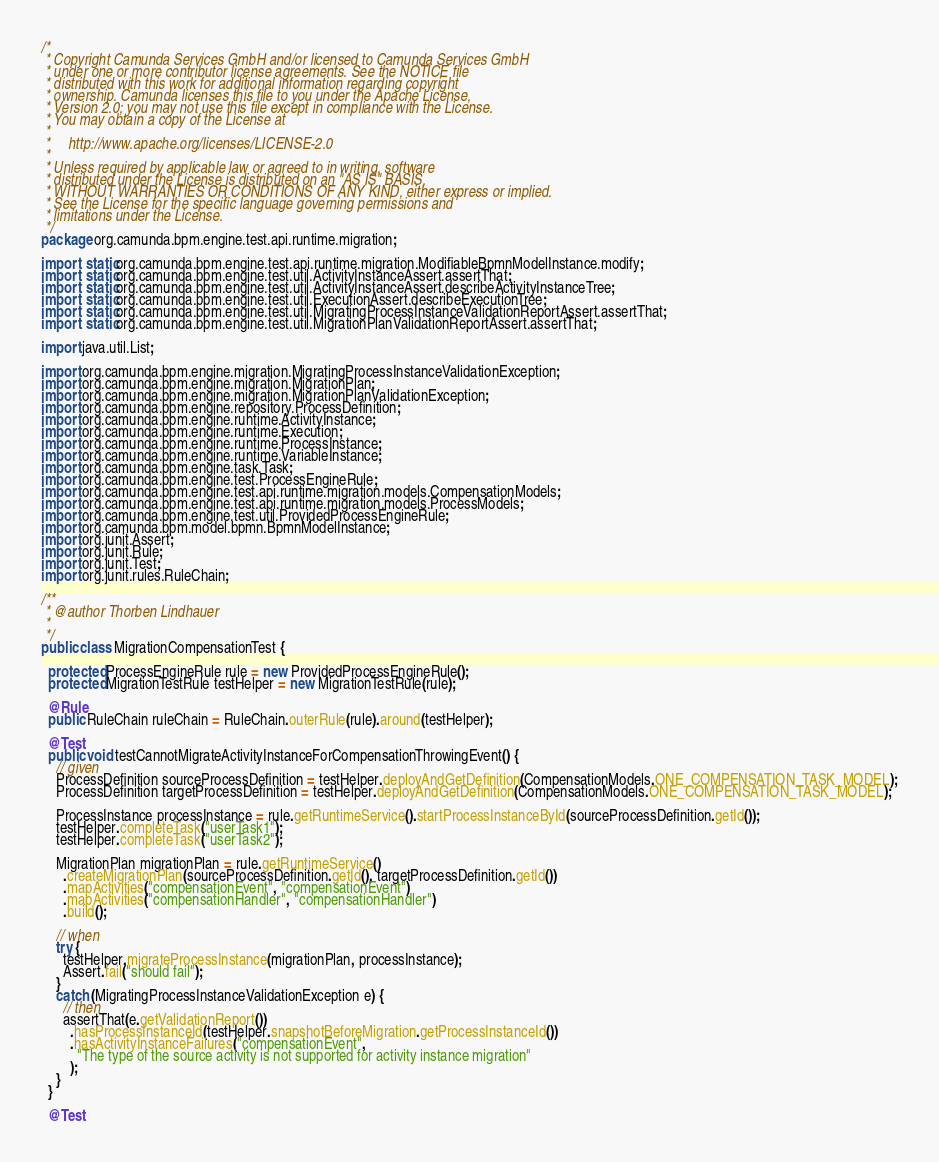Convert code to text. <code><loc_0><loc_0><loc_500><loc_500><_Java_>/*
 * Copyright Camunda Services GmbH and/or licensed to Camunda Services GmbH
 * under one or more contributor license agreements. See the NOTICE file
 * distributed with this work for additional information regarding copyright
 * ownership. Camunda licenses this file to you under the Apache License,
 * Version 2.0; you may not use this file except in compliance with the License.
 * You may obtain a copy of the License at
 *
 *     http://www.apache.org/licenses/LICENSE-2.0
 *
 * Unless required by applicable law or agreed to in writing, software
 * distributed under the License is distributed on an "AS IS" BASIS,
 * WITHOUT WARRANTIES OR CONDITIONS OF ANY KIND, either express or implied.
 * See the License for the specific language governing permissions and
 * limitations under the License.
 */
package org.camunda.bpm.engine.test.api.runtime.migration;

import static org.camunda.bpm.engine.test.api.runtime.migration.ModifiableBpmnModelInstance.modify;
import static org.camunda.bpm.engine.test.util.ActivityInstanceAssert.assertThat;
import static org.camunda.bpm.engine.test.util.ActivityInstanceAssert.describeActivityInstanceTree;
import static org.camunda.bpm.engine.test.util.ExecutionAssert.describeExecutionTree;
import static org.camunda.bpm.engine.test.util.MigratingProcessInstanceValidationReportAssert.assertThat;
import static org.camunda.bpm.engine.test.util.MigrationPlanValidationReportAssert.assertThat;

import java.util.List;

import org.camunda.bpm.engine.migration.MigratingProcessInstanceValidationException;
import org.camunda.bpm.engine.migration.MigrationPlan;
import org.camunda.bpm.engine.migration.MigrationPlanValidationException;
import org.camunda.bpm.engine.repository.ProcessDefinition;
import org.camunda.bpm.engine.runtime.ActivityInstance;
import org.camunda.bpm.engine.runtime.Execution;
import org.camunda.bpm.engine.runtime.ProcessInstance;
import org.camunda.bpm.engine.runtime.VariableInstance;
import org.camunda.bpm.engine.task.Task;
import org.camunda.bpm.engine.test.ProcessEngineRule;
import org.camunda.bpm.engine.test.api.runtime.migration.models.CompensationModels;
import org.camunda.bpm.engine.test.api.runtime.migration.models.ProcessModels;
import org.camunda.bpm.engine.test.util.ProvidedProcessEngineRule;
import org.camunda.bpm.model.bpmn.BpmnModelInstance;
import org.junit.Assert;
import org.junit.Rule;
import org.junit.Test;
import org.junit.rules.RuleChain;

/**
 * @author Thorben Lindhauer
 *
 */
public class MigrationCompensationTest {

  protected ProcessEngineRule rule = new ProvidedProcessEngineRule();
  protected MigrationTestRule testHelper = new MigrationTestRule(rule);

  @Rule
  public RuleChain ruleChain = RuleChain.outerRule(rule).around(testHelper);

  @Test
  public void testCannotMigrateActivityInstanceForCompensationThrowingEvent() {
    // given
    ProcessDefinition sourceProcessDefinition = testHelper.deployAndGetDefinition(CompensationModels.ONE_COMPENSATION_TASK_MODEL);
    ProcessDefinition targetProcessDefinition = testHelper.deployAndGetDefinition(CompensationModels.ONE_COMPENSATION_TASK_MODEL);

    ProcessInstance processInstance = rule.getRuntimeService().startProcessInstanceById(sourceProcessDefinition.getId());
    testHelper.completeTask("userTask1");
    testHelper.completeTask("userTask2");

    MigrationPlan migrationPlan = rule.getRuntimeService()
      .createMigrationPlan(sourceProcessDefinition.getId(), targetProcessDefinition.getId())
      .mapActivities("compensationEvent", "compensationEvent")
      .mapActivities("compensationHandler", "compensationHandler")
      .build();

    // when
    try {
      testHelper.migrateProcessInstance(migrationPlan, processInstance);
      Assert.fail("should fail");
    }
    catch (MigratingProcessInstanceValidationException e) {
      // then
      assertThat(e.getValidationReport())
        .hasProcessInstanceId(testHelper.snapshotBeforeMigration.getProcessInstanceId())
        .hasActivityInstanceFailures("compensationEvent",
          "The type of the source activity is not supported for activity instance migration"
        );
    }
  }

  @Test</code> 